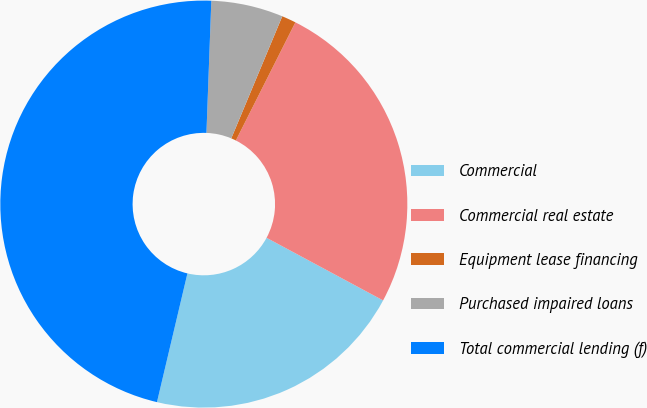Convert chart to OTSL. <chart><loc_0><loc_0><loc_500><loc_500><pie_chart><fcel>Commercial<fcel>Commercial real estate<fcel>Equipment lease financing<fcel>Purchased impaired loans<fcel>Total commercial lending (f)<nl><fcel>20.85%<fcel>25.42%<fcel>1.13%<fcel>5.71%<fcel>46.89%<nl></chart> 